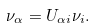<formula> <loc_0><loc_0><loc_500><loc_500>\nu _ { \alpha } = U _ { \alpha i } \nu _ { i } .</formula> 